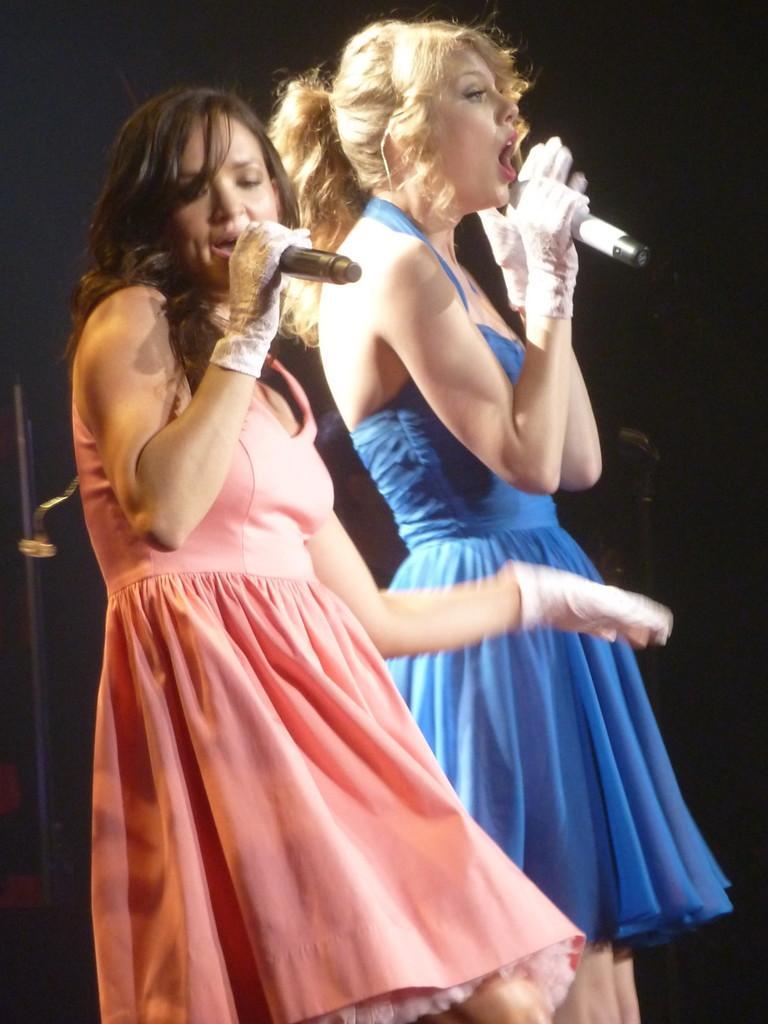Please provide a concise description of this image. In this image we can see there are two woman sings and are holding a microphone. 